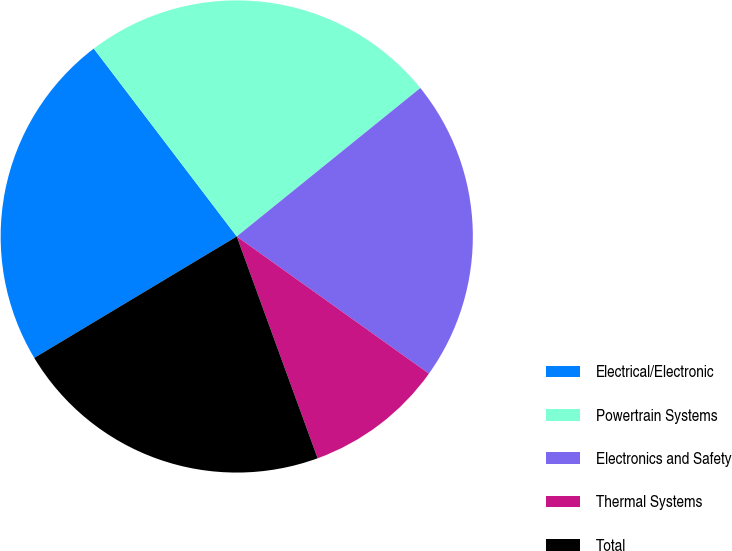Convert chart to OTSL. <chart><loc_0><loc_0><loc_500><loc_500><pie_chart><fcel>Electrical/Electronic<fcel>Powertrain Systems<fcel>Electronics and Safety<fcel>Thermal Systems<fcel>Total<nl><fcel>23.25%<fcel>24.53%<fcel>20.69%<fcel>9.57%<fcel>21.97%<nl></chart> 